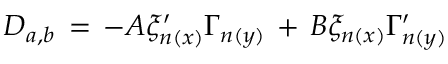Convert formula to latex. <formula><loc_0><loc_0><loc_500><loc_500>D _ { a , b } \, = \, - A \xi _ { n ( x ) } ^ { \prime } \Gamma _ { n ( y ) } \, + \, B \xi _ { n ( x ) } \Gamma _ { n ( y ) } ^ { \prime }</formula> 